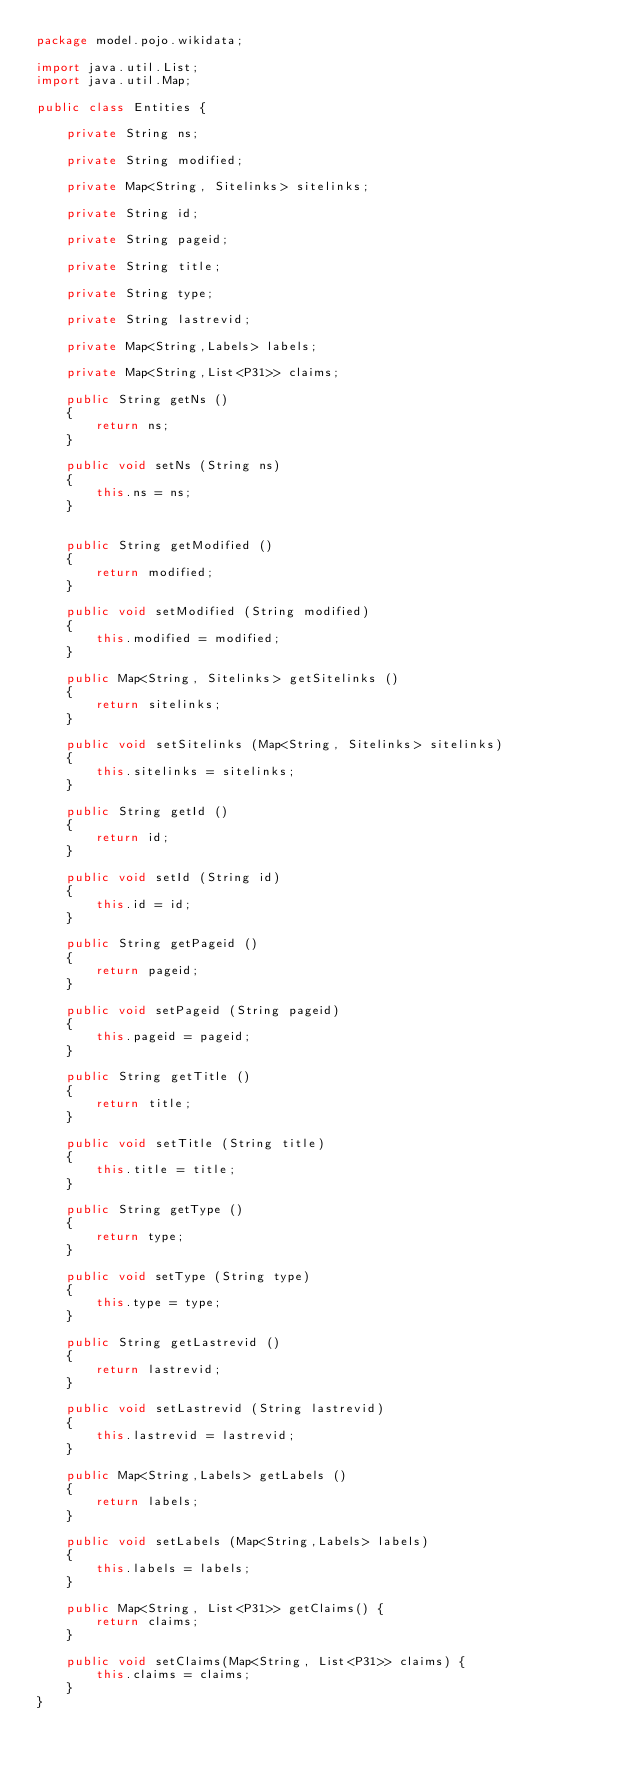Convert code to text. <code><loc_0><loc_0><loc_500><loc_500><_Java_>package model.pojo.wikidata;

import java.util.List;
import java.util.Map;

public class Entities {
	
    private String ns;

    private String modified;

    private Map<String, Sitelinks> sitelinks;

    private String id;

    private String pageid;

    private String title;

    private String type;

    private String lastrevid;
    
    private Map<String,Labels> labels;
    
    private Map<String,List<P31>> claims;

    public String getNs ()
    {
        return ns;
    }

    public void setNs (String ns)
    {
        this.ns = ns;
    }

   
    public String getModified ()
    {
        return modified;
    }

    public void setModified (String modified)
    {
        this.modified = modified;
    }

    public Map<String, Sitelinks> getSitelinks ()
    {
        return sitelinks;
    }

    public void setSitelinks (Map<String, Sitelinks> sitelinks)
    {
        this.sitelinks = sitelinks;
    }

    public String getId ()
    {
        return id;
    }

    public void setId (String id)
    {
        this.id = id;
    }

    public String getPageid ()
    {
        return pageid;
    }

    public void setPageid (String pageid)
    {
        this.pageid = pageid;
    }

    public String getTitle ()
    {
        return title;
    }

    public void setTitle (String title)
    {
        this.title = title;
    }

    public String getType ()
    {
        return type;
    }

    public void setType (String type)
    {
        this.type = type;
    }

    public String getLastrevid ()
    {
        return lastrevid;
    }

    public void setLastrevid (String lastrevid)
    {
        this.lastrevid = lastrevid;
    }

    public Map<String,Labels> getLabels ()
    {
        return labels;
    }

    public void setLabels (Map<String,Labels> labels)
    {
        this.labels = labels;
    }

	public Map<String, List<P31>> getClaims() {
		return claims;
	}

	public void setClaims(Map<String, List<P31>> claims) {
		this.claims = claims;
	}
}
</code> 